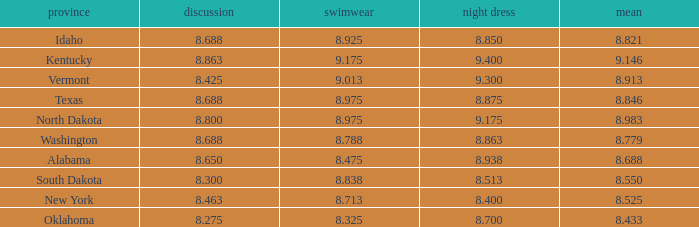What is the average interview score from Kentucky? 8.863. 